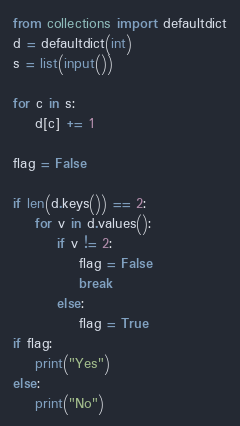<code> <loc_0><loc_0><loc_500><loc_500><_Python_>from collections import defaultdict
d = defaultdict(int)
s = list(input())

for c in s:
    d[c] += 1

flag = False

if len(d.keys()) == 2:
    for v in d.values():
        if v != 2:
            flag = False
            break
        else:
            flag = True
if flag:
    print("Yes")
else:
    print("No")


</code> 